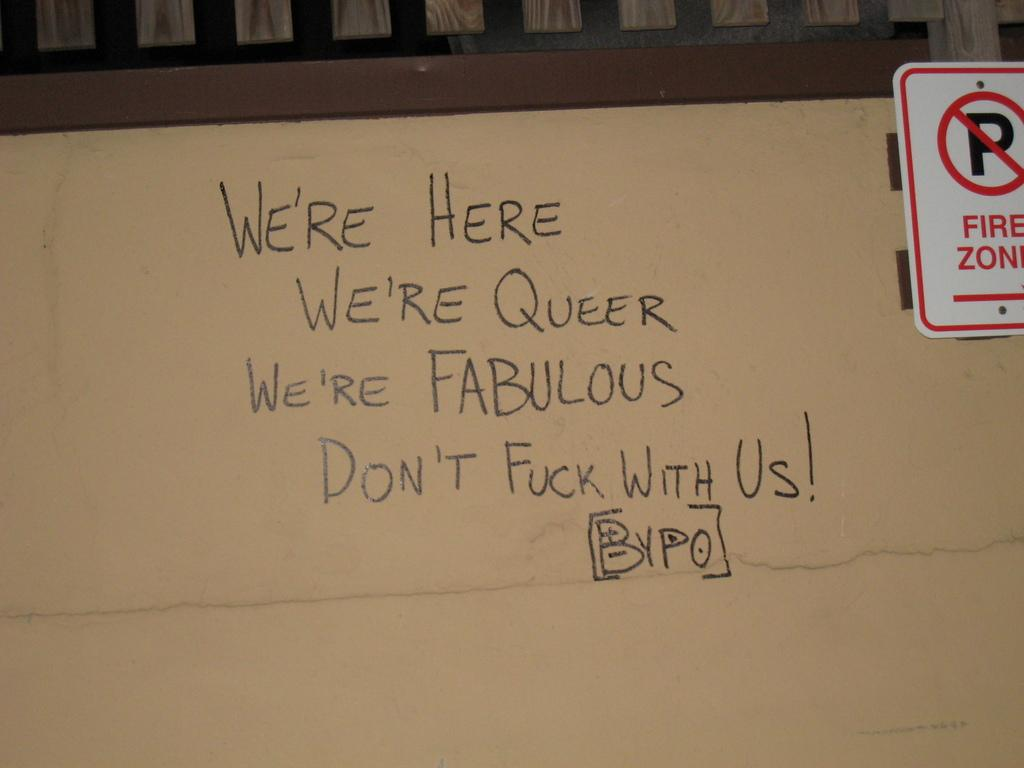Provide a one-sentence caption for the provided image. We're Here along with a few other chosen words is displayed along with a no parking fire zone sign. 